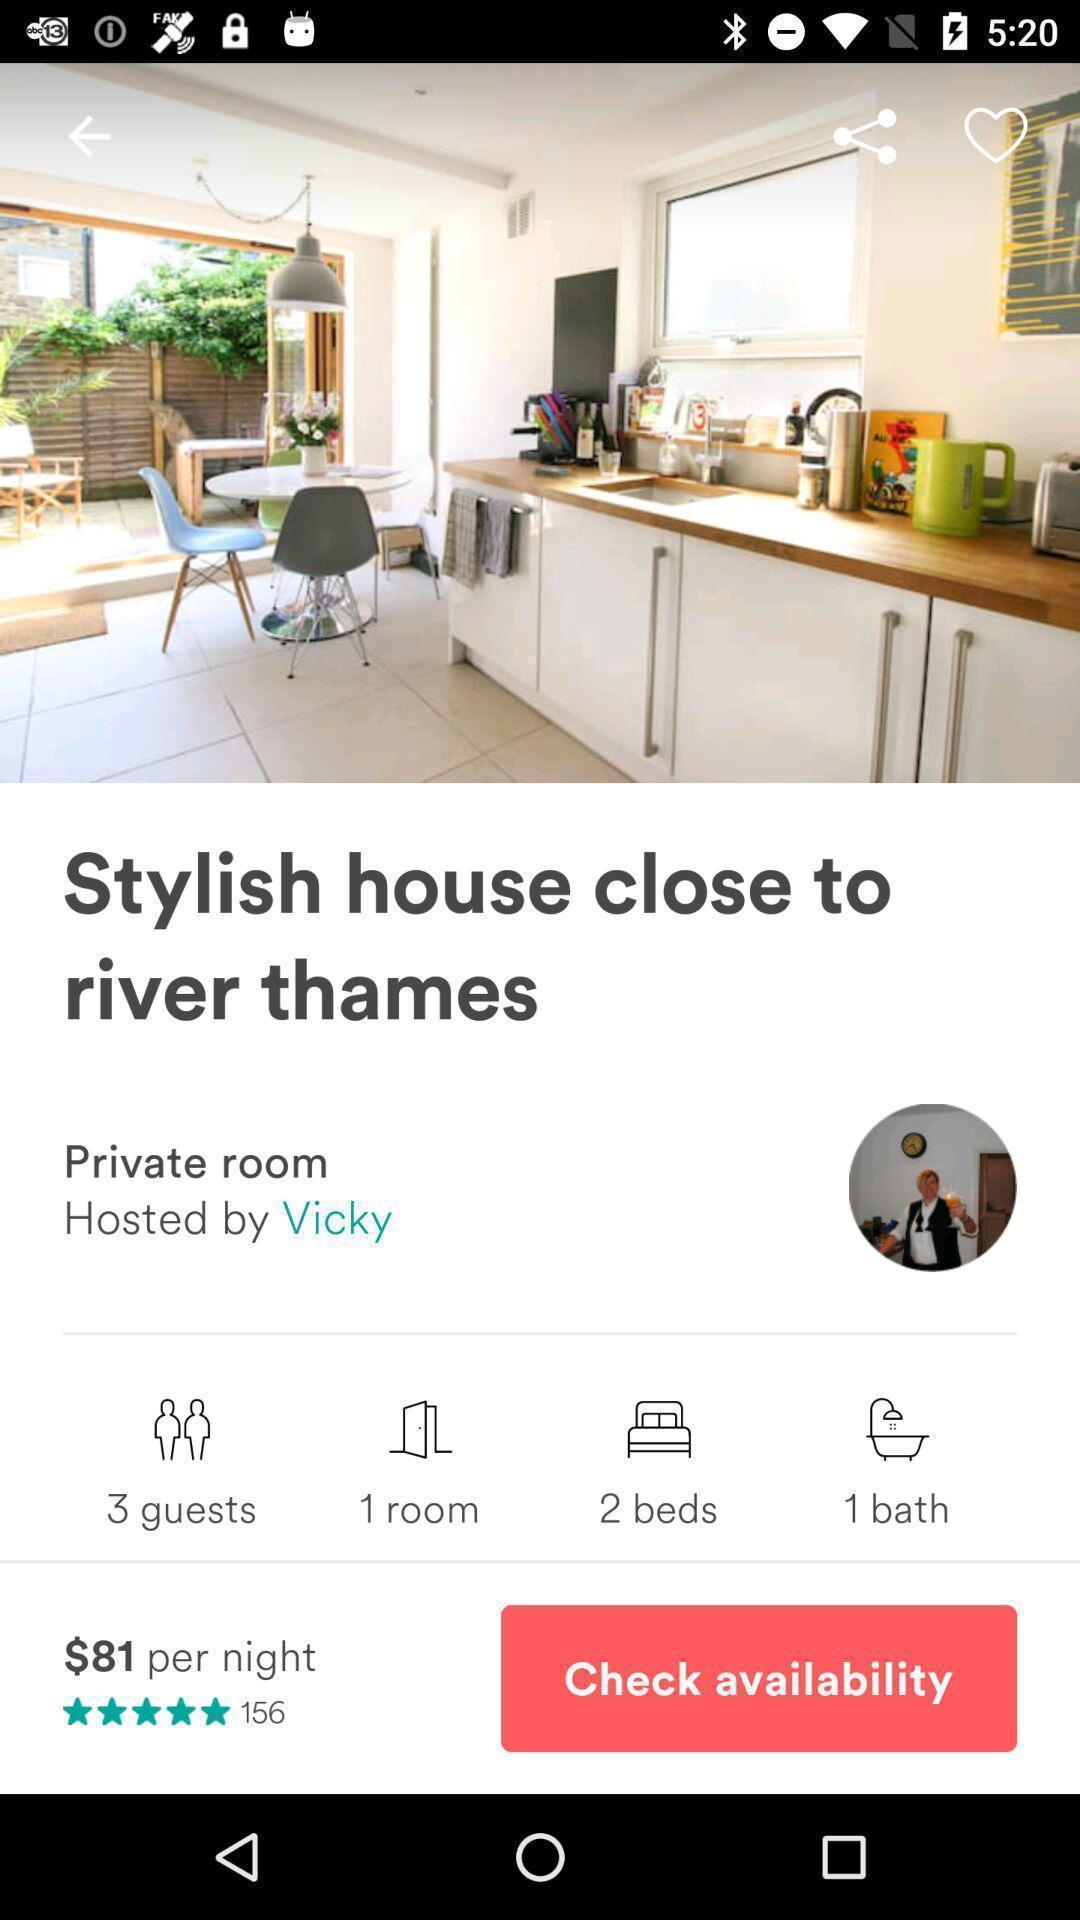Give me a summary of this screen capture. Window displaying a house for rent. 